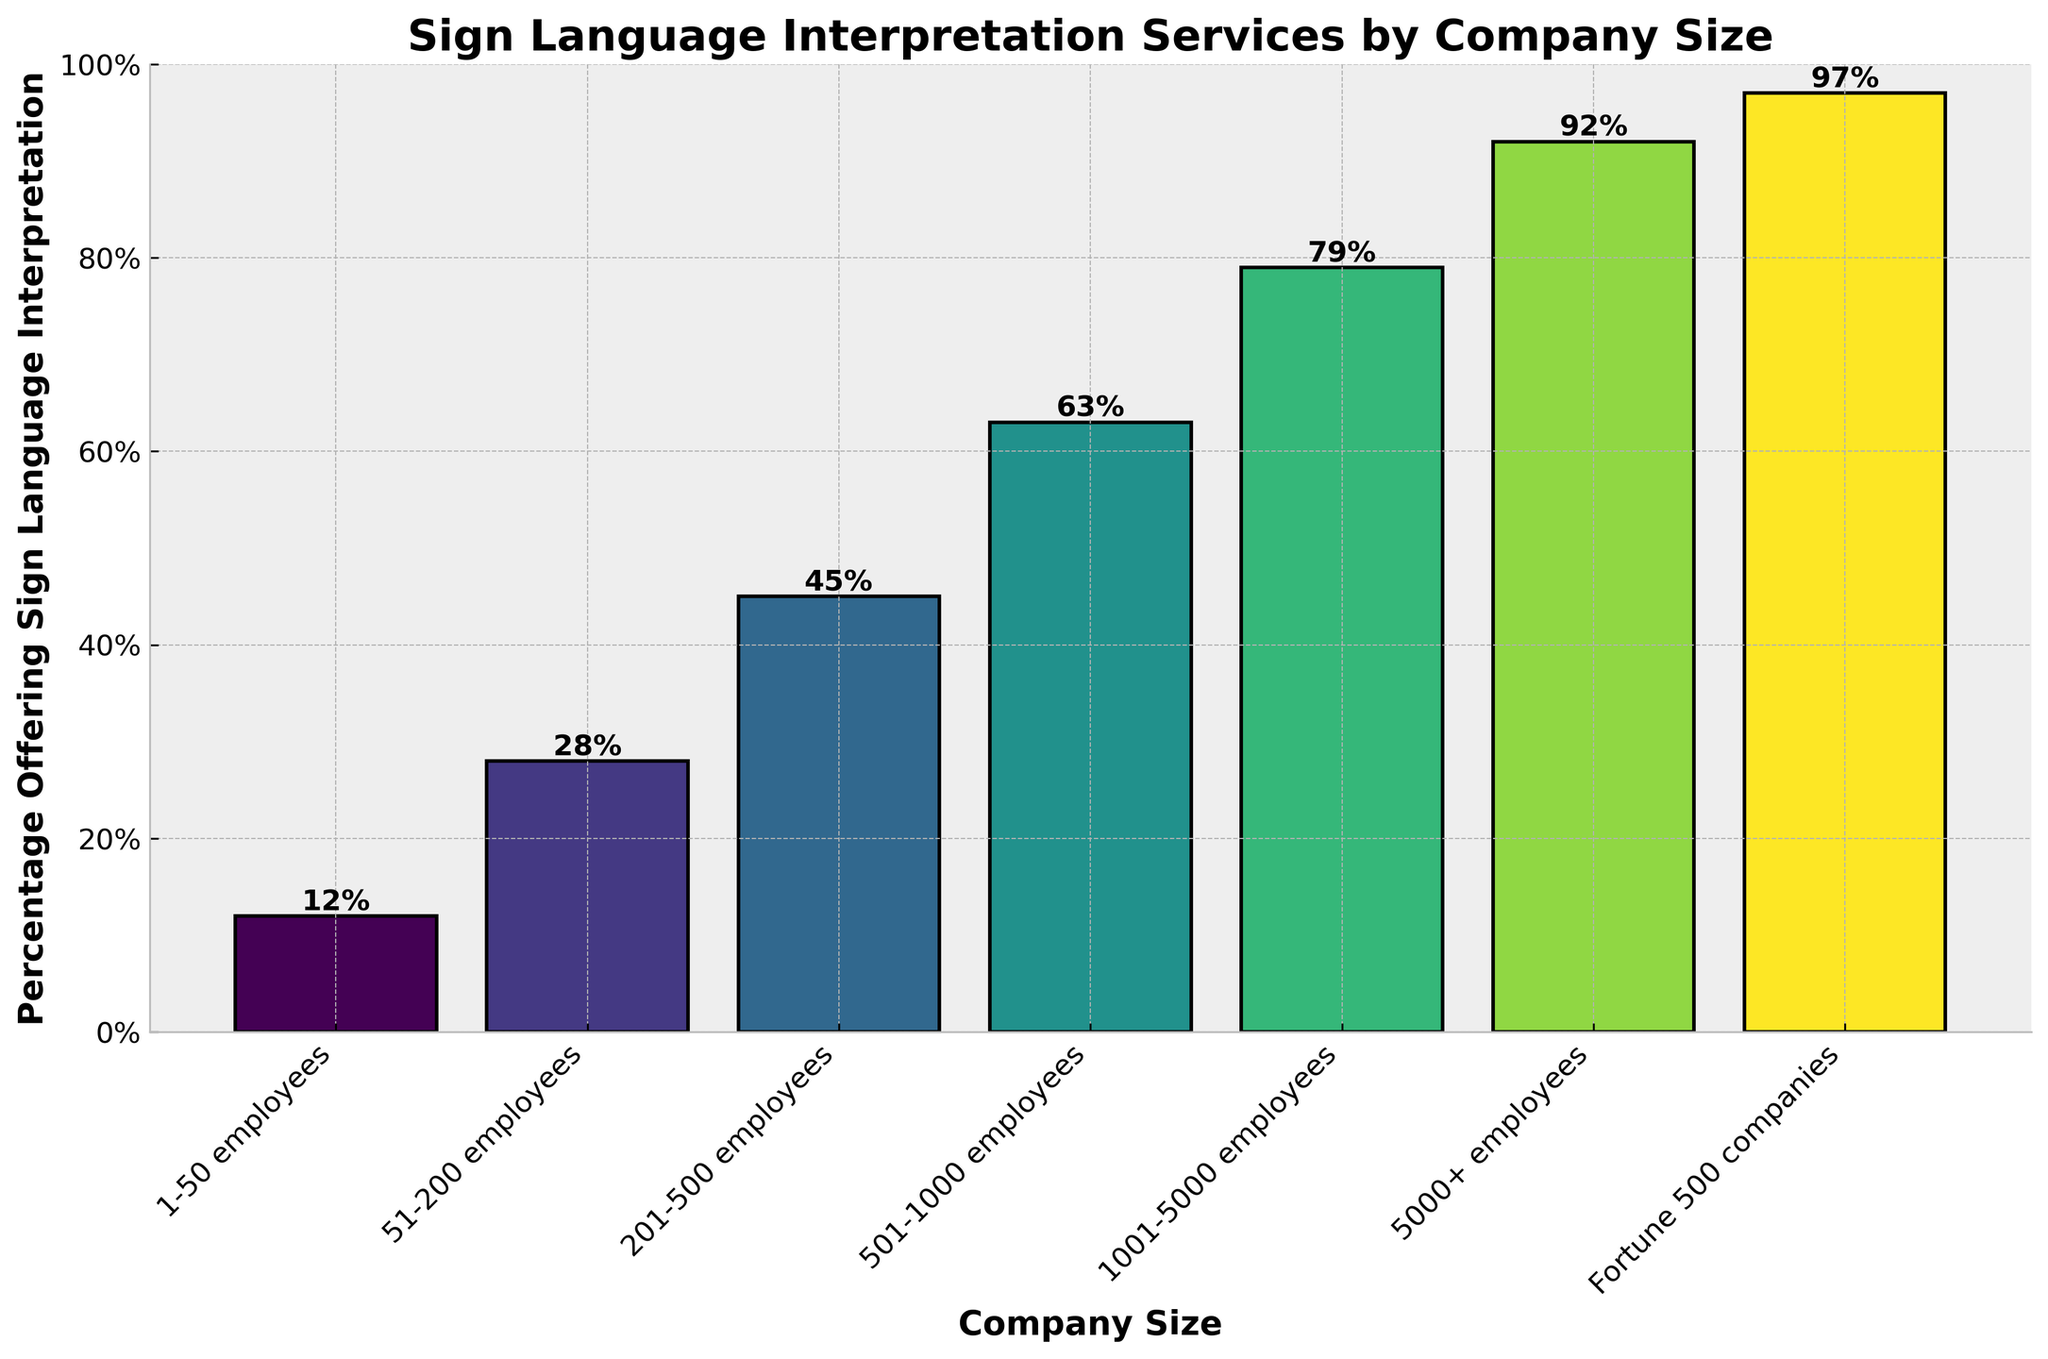How many company size categories offer sign language interpretation services to more than 50% of their employees? By examining the y-axis, locate the bars that reach above the 50% mark. These bars correspond to the company size categories that offer sign language interpretation services to more than 50% of their employees. Count these bars.
Answer: 4 Which company size category has the highest percentage of offering sign language interpretation services? Identify the tallest bar in the chart. The label at the base of this tallest bar represents the company size category with the highest percentage.
Answer: Fortune 500 companies What is the percentage difference in offering sign language interpretation services between companies with 51-200 employees and companies with 1001-5000 employees? Find the heights of the bars corresponding to "51-200 employees" and "1001-5000 employees." Subtract the smaller percentage from the larger one.
Answer: 51% How many company size categories have less than 30% of companies offering sign language interpretation services? Examine the bars below the 30% mark on the y-axis and count them.
Answer: 2 Which company size category has the bar colored in the lightest shade of green? Identify the bar that appears the lightest in color. The label at the base of the lightest bar indicates the company size category.
Answer: 1-50 employees For companies with 1-50 employees, what is the percentage of companies offering sign language interpretation services? Look at the height of the bar corresponding to "1-50 employees" and read the percentage value indicated.
Answer: 12% Compare the percentage of companies offering sign language interpretation services in the 201-500 employees category to the 5000+ employees category. Which offers more, and by how much? Identify the heights of the bars for both categories and subtract the smaller percentage from the larger one. Determine which category has the greater value.
Answer: 5000+ employees offer 47% more 